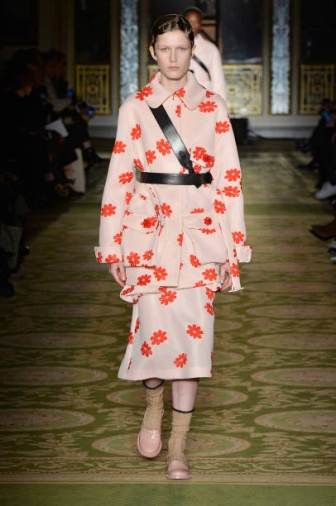Who do you think is the designer of the model's dress? While the image does not provide information on the designer, the dress's unique combination of patterns and colors suggests it could be the work of a designer known for their bold and creative approach. Designers like Alessandro Michele or Jeremy Scott, known for their vibrant and eclectic styles, might have created such an ensemble. However, without specific information, this remains a speculative guess. What key elements do you notice in the room's decor? The room's decor prominently features elaborate gold detailing, indicating a sense of grandeur and sophistication. The intricate patterns on the walls and around the windows add a touch of aristocratic elegance. The lighting appears to be soft and ambient, enhancing the luxurious ambiance. The green runway provides a striking contrast to the gold decor, drawing attention and adding a modern touch to the classic opulence of the room. 